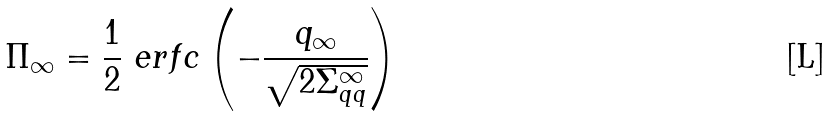<formula> <loc_0><loc_0><loc_500><loc_500>\Pi _ { \infty } = \frac { 1 } { 2 } \ e r f c \left ( - \frac { q _ { \infty } } { \sqrt { 2 \Sigma _ { q q } ^ { \infty } } } \right )</formula> 